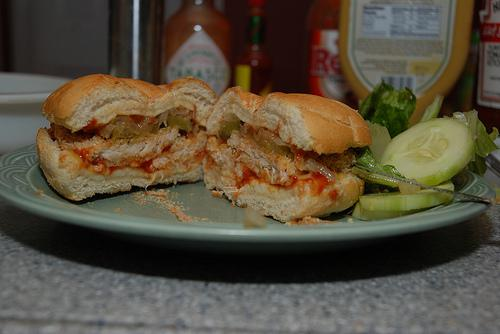Question: what color is the plate?
Choices:
A. White.
B. Black.
C. Red.
D. Blue.
Answer with the letter. Answer: D Question: what color sauce is on the sandwich?
Choices:
A. White.
B. Yellow.
C. Green.
D. Red.
Answer with the letter. Answer: D Question: how many halves of sandwich are there?
Choices:
A. Four.
B. Five.
C. Two.
D. Six.
Answer with the letter. Answer: C Question: where is the sandwich?
Choices:
A. On the plate.
B. In the floor.
C. In his mouth.
D. In the garbage.
Answer with the letter. Answer: A 